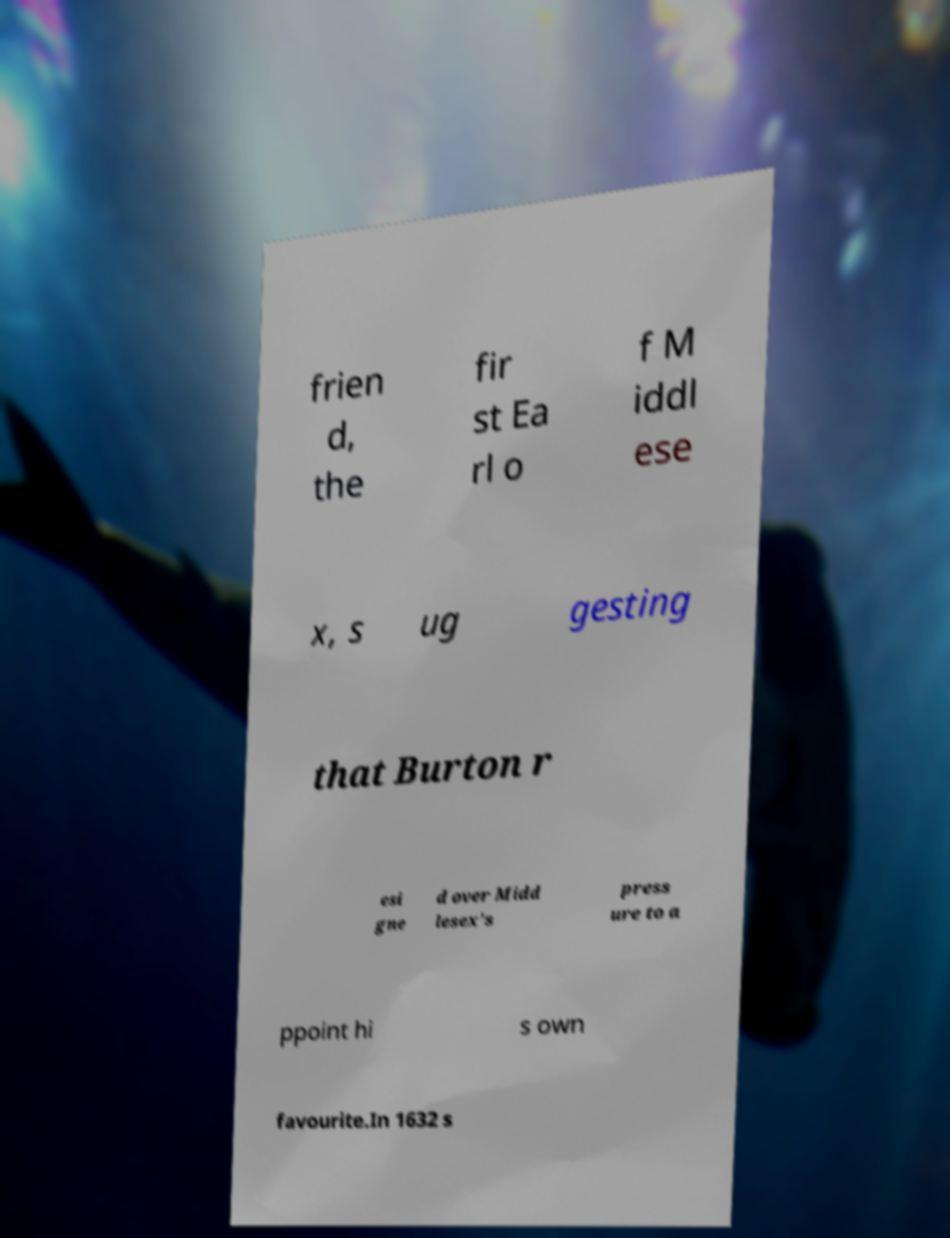Please identify and transcribe the text found in this image. frien d, the fir st Ea rl o f M iddl ese x, s ug gesting that Burton r esi gne d over Midd lesex's press ure to a ppoint hi s own favourite.In 1632 s 